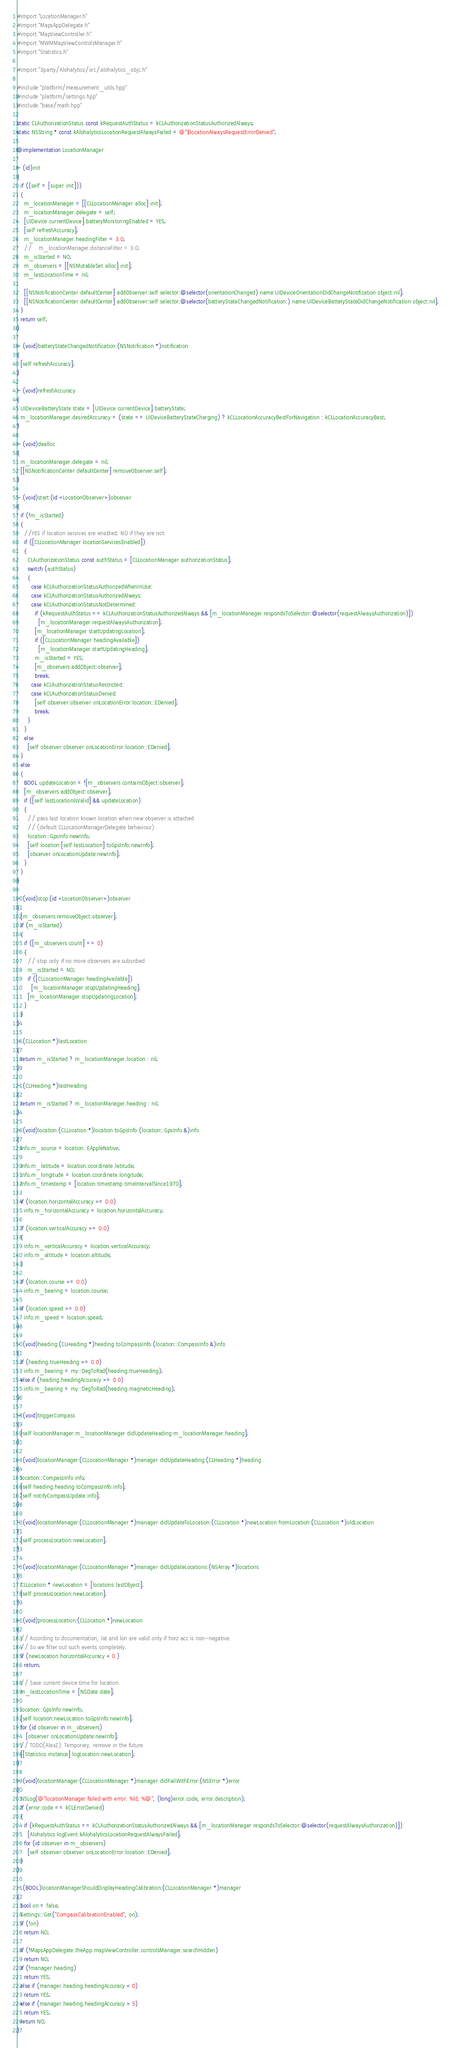<code> <loc_0><loc_0><loc_500><loc_500><_ObjectiveC_>#import "LocationManager.h"
#import "MapsAppDelegate.h"
#import "MapViewController.h"
#import "MWMMapViewControlsManager.h"
#import "Statistics.h"

#import "3party/Alohalytics/src/alohalytics_objc.h"

#include "platform/measurement_utils.hpp"
#include "platform/settings.hpp"
#include "base/math.hpp"

static CLAuthorizationStatus const kRequestAuthStatus = kCLAuthorizationStatusAuthorizedAlways;
static NSString * const kAlohalyticsLocationRequestAlwaysFailed = @"$locationAlwaysRequestErrorDenied";

@implementation LocationManager

- (id)init
{
  if ((self = [super init]))
  {
    m_locationManager = [[CLLocationManager alloc] init];
    m_locationManager.delegate = self;
    [UIDevice currentDevice].batteryMonitoringEnabled = YES;
    [self refreshAccuracy];
    m_locationManager.headingFilter = 3.0;
    //    m_locationManager.distanceFilter = 3.0;
    m_isStarted = NO;
    m_observers = [[NSMutableSet alloc] init];
    m_lastLocationTime = nil;

    [[NSNotificationCenter defaultCenter] addObserver:self selector:@selector(orientationChanged) name:UIDeviceOrientationDidChangeNotification object:nil];
    [[NSNotificationCenter defaultCenter] addObserver:self selector:@selector(batteryStateChangedNotification:) name:UIDeviceBatteryStateDidChangeNotification object:nil];
  }
  return self;
}

- (void)batteryStateChangedNotification:(NSNotification *)notification
{
  [self refreshAccuracy];
}

- (void)refreshAccuracy
{
  UIDeviceBatteryState state = [UIDevice currentDevice].batteryState;
  m_locationManager.desiredAccuracy = (state == UIDeviceBatteryStateCharging) ? kCLLocationAccuracyBestForNavigation : kCLLocationAccuracyBest;
}

- (void)dealloc
{
  m_locationManager.delegate = nil;
  [[NSNotificationCenter defaultCenter] removeObserver:self];
}

- (void)start:(id <LocationObserver>)observer
{
  if (!m_isStarted)
  {
    //YES if location services are enabled; NO if they are not.
    if ([CLLocationManager locationServicesEnabled])
    {
      CLAuthorizationStatus const authStatus = [CLLocationManager authorizationStatus];
      switch (authStatus)
      {
        case kCLAuthorizationStatusAuthorizedWhenInUse:
        case kCLAuthorizationStatusAuthorizedAlways:
        case kCLAuthorizationStatusNotDetermined:
          if (kRequestAuthStatus == kCLAuthorizationStatusAuthorizedAlways && [m_locationManager respondsToSelector:@selector(requestAlwaysAuthorization)])
            [m_locationManager requestAlwaysAuthorization];
          [m_locationManager startUpdatingLocation];
          if ([CLLocationManager headingAvailable])
            [m_locationManager startUpdatingHeading];
          m_isStarted = YES;
          [m_observers addObject:observer];
          break;
        case kCLAuthorizationStatusRestricted:
        case kCLAuthorizationStatusDenied:
          [self observer:observer onLocationError:location::EDenied];
          break;
      }
    }
    else
      [self observer:observer onLocationError:location::EDenied];
  }
  else
  {
    BOOL updateLocation = ![m_observers containsObject:observer];
    [m_observers addObject:observer];
    if ([self lastLocationIsValid] && updateLocation)
    {
      // pass last location known location when new observer is attached
      // (default CLLocationManagerDelegate behaviour)
      location::GpsInfo newInfo;
      [self location:[self lastLocation] toGpsInfo:newInfo];
      [observer onLocationUpdate:newInfo];
    }
  }
}

- (void)stop:(id <LocationObserver>)observer
{
  [m_observers removeObject:observer];
  if (m_isStarted)
  {
    if ([m_observers count] == 0)
    {
      // stop only if no more observers are subsribed
      m_isStarted = NO;
      if ([CLLocationManager headingAvailable])
        [m_locationManager stopUpdatingHeading];
      [m_locationManager stopUpdatingLocation];
    }
  }
}

- (CLLocation *)lastLocation
{
  return m_isStarted ? m_locationManager.location : nil;
}

- (CLHeading *)lastHeading
{
  return m_isStarted ? m_locationManager.heading : nil;
}

- (void)location:(CLLocation *)location toGpsInfo:(location::GpsInfo &)info
{
  info.m_source = location::EAppleNative;

  info.m_latitude = location.coordinate.latitude;
  info.m_longitude = location.coordinate.longitude;
  info.m_timestamp = [location.timestamp timeIntervalSince1970];

  if (location.horizontalAccuracy >= 0.0)
    info.m_horizontalAccuracy = location.horizontalAccuracy;

  if (location.verticalAccuracy >= 0.0)
  {
    info.m_verticalAccuracy = location.verticalAccuracy;
    info.m_altitude = location.altitude;
  }

  if (location.course >= 0.0)
    info.m_bearing = location.course;

  if (location.speed >= 0.0)
    info.m_speed = location.speed;
}

- (void)heading:(CLHeading *)heading toCompassInfo:(location::CompassInfo &)info
{
  if (heading.trueHeading >= 0.0)
    info.m_bearing = my::DegToRad(heading.trueHeading);
  else if (heading.headingAccuracy >= 0.0)
    info.m_bearing = my::DegToRad(heading.magneticHeading);
}

- (void)triggerCompass
{
  [self locationManager:m_locationManager didUpdateHeading:m_locationManager.heading];
}

- (void)locationManager:(CLLocationManager *)manager didUpdateHeading:(CLHeading *)heading
{
  location::CompassInfo info;
  [self heading:heading toCompassInfo:info];
  [self notifyCompassUpdate:info];
}

- (void)locationManager:(CLLocationManager *)manager didUpdateToLocation:(CLLocation *)newLocation fromLocation:(CLLocation *)oldLocation
{
  [self processLocation:newLocation];
}

- (void)locationManager:(CLLocationManager *)manager didUpdateLocations:(NSArray *)locations
{
  CLLocation * newLocation = [locations lastObject];
  [self processLocation:newLocation];
}

- (void)processLocation:(CLLocation *)newLocation
{
  // According to documentation, lat and lon are valid only if horz acc is non-negative.
  // So we filter out such events completely.
  if (newLocation.horizontalAccuracy < 0.)
    return;

  // Save current device time for location.
  m_lastLocationTime = [NSDate date];

  location::GpsInfo newInfo;
  [self location:newLocation toGpsInfo:newInfo];
  for (id observer in m_observers)
     [observer onLocationUpdate:newInfo];
  // TODO(AlexZ): Temporary, remove in the future.
  [[Statistics instance] logLocation:newLocation];
}

- (void)locationManager:(CLLocationManager *)manager didFailWithError:(NSError *)error
{
  NSLog(@"locationManager failed with error: %ld, %@", (long)error.code, error.description);
  if (error.code == kCLErrorDenied)
  {
    if (kRequestAuthStatus == kCLAuthorizationStatusAuthorizedAlways && [m_locationManager respondsToSelector:@selector(requestAlwaysAuthorization)])
      [Alohalytics logEvent:kAlohalyticsLocationRequestAlwaysFailed];
    for (id observer in m_observers)
      [self observer:observer onLocationError:location::EDenied];
  }
}

- (BOOL)locationManagerShouldDisplayHeadingCalibration:(CLLocationManager *)manager
{
  bool on = false;
  Settings::Get("CompassCalibrationEnabled", on);
  if (!on)
    return NO;

  if (!MapsAppDelegate.theApp.mapViewController.controlsManager.searchHidden)
    return NO;
  if (!manager.heading)
    return YES;
  else if (manager.heading.headingAccuracy < 0)
    return YES;
  else if (manager.heading.headingAccuracy > 5)
    return YES;
  return NO;
}
</code> 